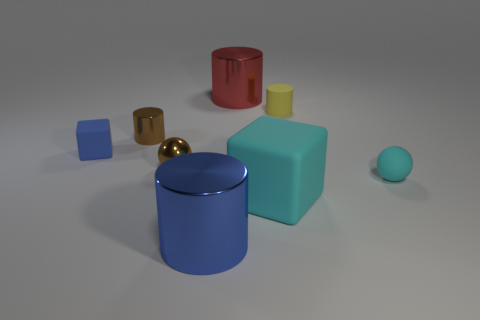Do the matte sphere and the large matte object have the same color?
Make the answer very short. Yes. Is the material of the small brown cylinder that is behind the tiny brown metallic ball the same as the tiny blue cube?
Keep it short and to the point. No. What number of spheres are to the right of the metallic ball and to the left of the small matte cylinder?
Your answer should be very brief. 0. What number of cyan things are the same material as the blue cylinder?
Your response must be concise. 0. There is a tiny ball that is the same material as the small brown cylinder; what color is it?
Your answer should be very brief. Brown. Are there fewer tiny rubber cylinders than tiny cyan rubber cylinders?
Your answer should be very brief. No. There is a cylinder left of the brown object right of the small cylinder to the left of the large rubber cube; what is its material?
Ensure brevity in your answer.  Metal. What is the big red object made of?
Provide a succinct answer. Metal. Is the color of the block in front of the small metallic ball the same as the large metal cylinder that is in front of the tiny shiny sphere?
Offer a terse response. No. Is the number of small yellow cylinders greater than the number of cyan rubber objects?
Your answer should be compact. No. 